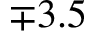<formula> <loc_0><loc_0><loc_500><loc_500>\mp 3 . 5</formula> 